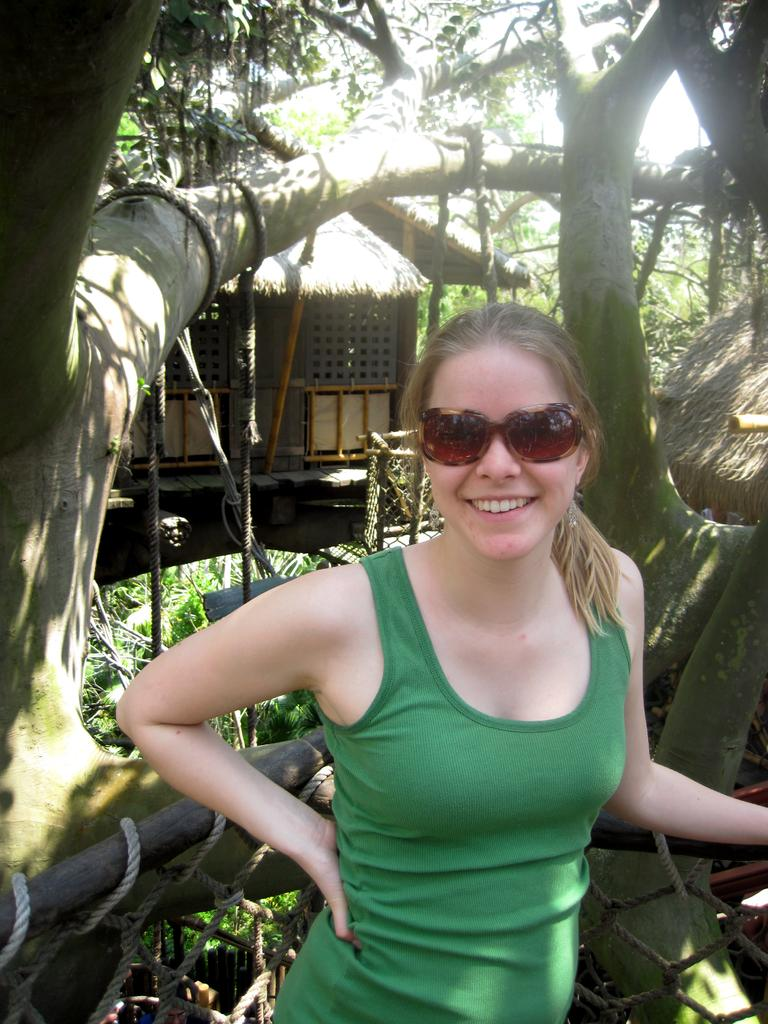Who is the main subject in the image? There is a girl standing in the center of the image. What can be seen in the background of the image? There is a wooden hut, trees, plants, and the sky visible in the background of the image. What type of knot is the girl using to secure her vest in the image? There is no knot or vest present in the image. What type of seat is the girl sitting on in the image? The girl is standing in the image, so there is no seat present. 